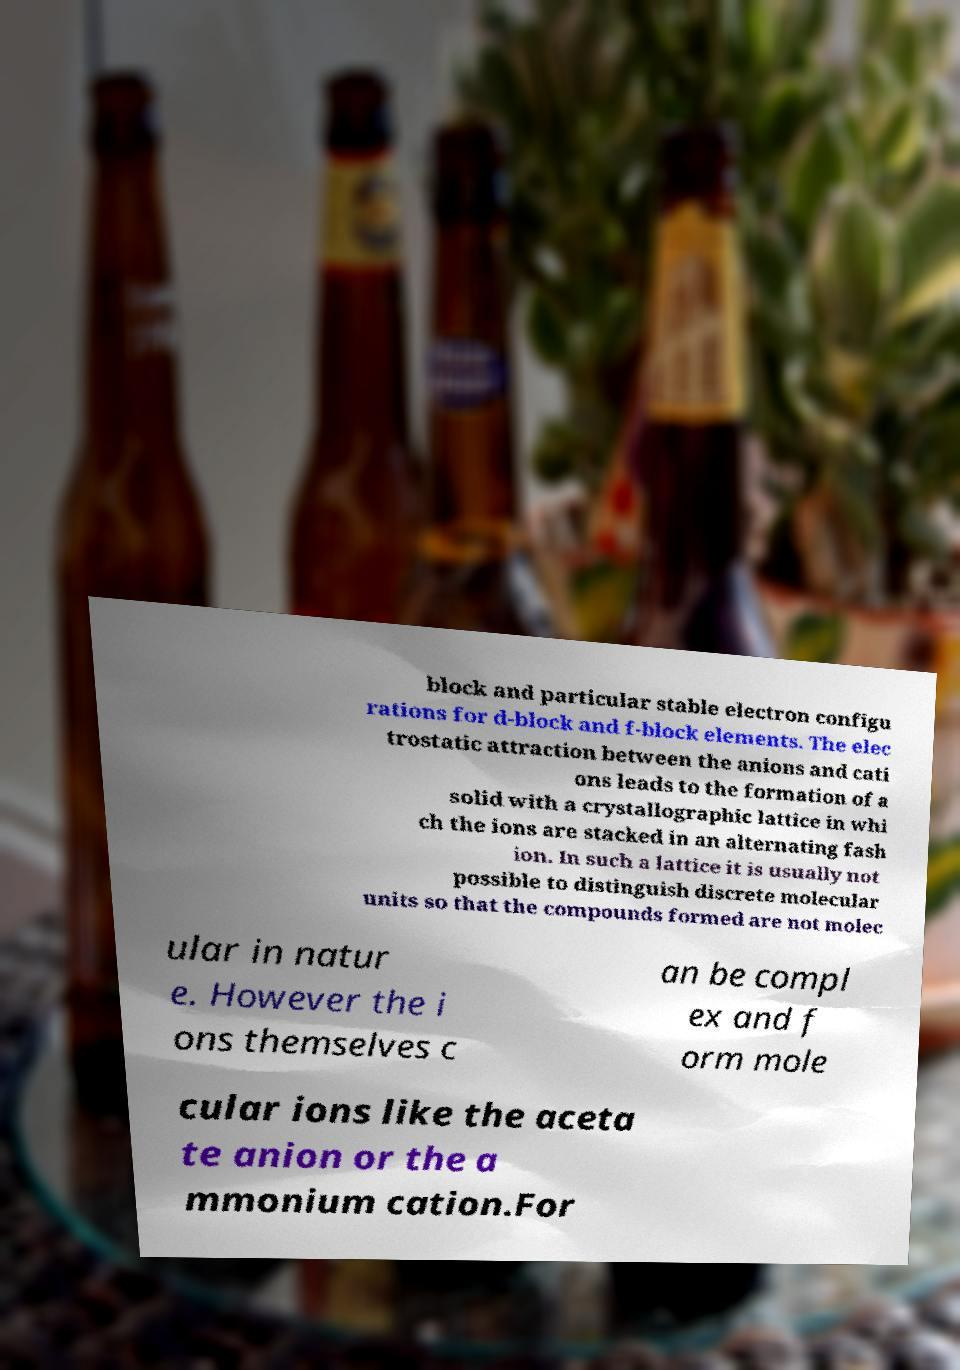Please read and relay the text visible in this image. What does it say? block and particular stable electron configu rations for d-block and f-block elements. The elec trostatic attraction between the anions and cati ons leads to the formation of a solid with a crystallographic lattice in whi ch the ions are stacked in an alternating fash ion. In such a lattice it is usually not possible to distinguish discrete molecular units so that the compounds formed are not molec ular in natur e. However the i ons themselves c an be compl ex and f orm mole cular ions like the aceta te anion or the a mmonium cation.For 